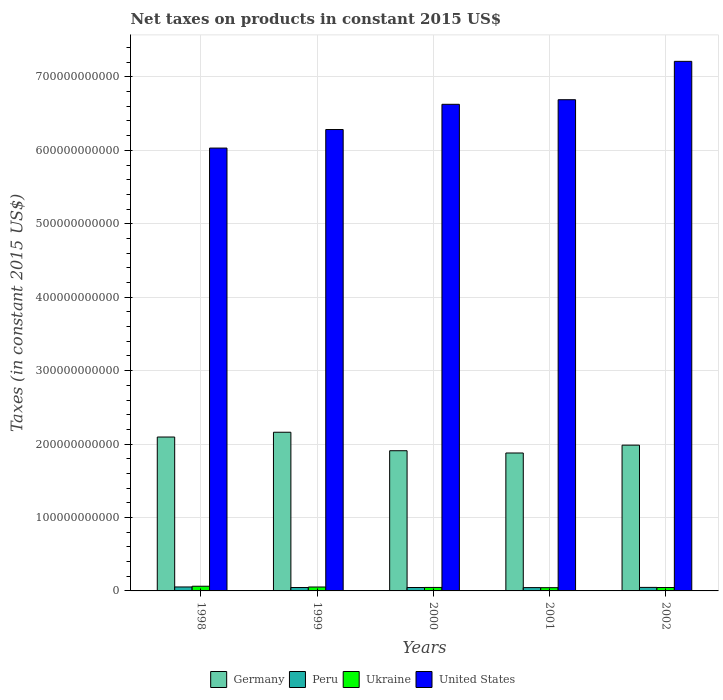How many different coloured bars are there?
Your answer should be compact. 4. Are the number of bars per tick equal to the number of legend labels?
Your response must be concise. Yes. How many bars are there on the 2nd tick from the left?
Offer a terse response. 4. In how many cases, is the number of bars for a given year not equal to the number of legend labels?
Offer a very short reply. 0. What is the net taxes on products in United States in 2002?
Provide a succinct answer. 7.21e+11. Across all years, what is the maximum net taxes on products in Ukraine?
Provide a short and direct response. 6.38e+09. Across all years, what is the minimum net taxes on products in United States?
Your answer should be compact. 6.03e+11. What is the total net taxes on products in United States in the graph?
Your answer should be compact. 3.28e+12. What is the difference between the net taxes on products in Peru in 1999 and that in 2000?
Ensure brevity in your answer.  -1.66e+07. What is the difference between the net taxes on products in Peru in 2001 and the net taxes on products in Ukraine in 1999?
Your response must be concise. -7.92e+08. What is the average net taxes on products in United States per year?
Ensure brevity in your answer.  6.57e+11. In the year 2001, what is the difference between the net taxes on products in United States and net taxes on products in Germany?
Offer a terse response. 4.81e+11. In how many years, is the net taxes on products in Peru greater than 40000000000 US$?
Provide a succinct answer. 0. What is the ratio of the net taxes on products in Germany in 1999 to that in 2001?
Your response must be concise. 1.15. Is the net taxes on products in Peru in 1999 less than that in 2000?
Provide a succinct answer. Yes. Is the difference between the net taxes on products in United States in 2000 and 2001 greater than the difference between the net taxes on products in Germany in 2000 and 2001?
Your response must be concise. No. What is the difference between the highest and the second highest net taxes on products in United States?
Offer a terse response. 5.22e+1. What is the difference between the highest and the lowest net taxes on products in Ukraine?
Provide a short and direct response. 1.97e+09. In how many years, is the net taxes on products in Peru greater than the average net taxes on products in Peru taken over all years?
Offer a very short reply. 1. Is the sum of the net taxes on products in Peru in 2000 and 2002 greater than the maximum net taxes on products in United States across all years?
Keep it short and to the point. No. Is it the case that in every year, the sum of the net taxes on products in United States and net taxes on products in Peru is greater than the sum of net taxes on products in Ukraine and net taxes on products in Germany?
Your answer should be compact. Yes. How many bars are there?
Your response must be concise. 20. Are all the bars in the graph horizontal?
Make the answer very short. No. How many years are there in the graph?
Make the answer very short. 5. What is the difference between two consecutive major ticks on the Y-axis?
Make the answer very short. 1.00e+11. Where does the legend appear in the graph?
Ensure brevity in your answer.  Bottom center. How many legend labels are there?
Provide a succinct answer. 4. What is the title of the graph?
Provide a succinct answer. Net taxes on products in constant 2015 US$. What is the label or title of the Y-axis?
Provide a succinct answer. Taxes (in constant 2015 US$). What is the Taxes (in constant 2015 US$) of Germany in 1998?
Provide a short and direct response. 2.10e+11. What is the Taxes (in constant 2015 US$) in Peru in 1998?
Provide a short and direct response. 5.39e+09. What is the Taxes (in constant 2015 US$) of Ukraine in 1998?
Give a very brief answer. 6.38e+09. What is the Taxes (in constant 2015 US$) of United States in 1998?
Keep it short and to the point. 6.03e+11. What is the Taxes (in constant 2015 US$) of Germany in 1999?
Give a very brief answer. 2.16e+11. What is the Taxes (in constant 2015 US$) in Peru in 1999?
Ensure brevity in your answer.  4.64e+09. What is the Taxes (in constant 2015 US$) in Ukraine in 1999?
Offer a terse response. 5.32e+09. What is the Taxes (in constant 2015 US$) in United States in 1999?
Keep it short and to the point. 6.28e+11. What is the Taxes (in constant 2015 US$) of Germany in 2000?
Offer a very short reply. 1.91e+11. What is the Taxes (in constant 2015 US$) of Peru in 2000?
Your response must be concise. 4.65e+09. What is the Taxes (in constant 2015 US$) in Ukraine in 2000?
Give a very brief answer. 4.74e+09. What is the Taxes (in constant 2015 US$) of United States in 2000?
Ensure brevity in your answer.  6.63e+11. What is the Taxes (in constant 2015 US$) in Germany in 2001?
Make the answer very short. 1.88e+11. What is the Taxes (in constant 2015 US$) of Peru in 2001?
Offer a very short reply. 4.53e+09. What is the Taxes (in constant 2015 US$) of Ukraine in 2001?
Provide a succinct answer. 4.41e+09. What is the Taxes (in constant 2015 US$) in United States in 2001?
Make the answer very short. 6.69e+11. What is the Taxes (in constant 2015 US$) of Germany in 2002?
Your answer should be compact. 1.99e+11. What is the Taxes (in constant 2015 US$) in Peru in 2002?
Your response must be concise. 4.80e+09. What is the Taxes (in constant 2015 US$) in Ukraine in 2002?
Offer a very short reply. 4.62e+09. What is the Taxes (in constant 2015 US$) in United States in 2002?
Ensure brevity in your answer.  7.21e+11. Across all years, what is the maximum Taxes (in constant 2015 US$) in Germany?
Ensure brevity in your answer.  2.16e+11. Across all years, what is the maximum Taxes (in constant 2015 US$) of Peru?
Offer a terse response. 5.39e+09. Across all years, what is the maximum Taxes (in constant 2015 US$) in Ukraine?
Offer a terse response. 6.38e+09. Across all years, what is the maximum Taxes (in constant 2015 US$) in United States?
Ensure brevity in your answer.  7.21e+11. Across all years, what is the minimum Taxes (in constant 2015 US$) of Germany?
Keep it short and to the point. 1.88e+11. Across all years, what is the minimum Taxes (in constant 2015 US$) in Peru?
Give a very brief answer. 4.53e+09. Across all years, what is the minimum Taxes (in constant 2015 US$) in Ukraine?
Make the answer very short. 4.41e+09. Across all years, what is the minimum Taxes (in constant 2015 US$) of United States?
Offer a very short reply. 6.03e+11. What is the total Taxes (in constant 2015 US$) of Germany in the graph?
Give a very brief answer. 1.00e+12. What is the total Taxes (in constant 2015 US$) of Peru in the graph?
Your answer should be compact. 2.40e+1. What is the total Taxes (in constant 2015 US$) of Ukraine in the graph?
Ensure brevity in your answer.  2.55e+1. What is the total Taxes (in constant 2015 US$) of United States in the graph?
Ensure brevity in your answer.  3.28e+12. What is the difference between the Taxes (in constant 2015 US$) of Germany in 1998 and that in 1999?
Provide a succinct answer. -6.52e+09. What is the difference between the Taxes (in constant 2015 US$) of Peru in 1998 and that in 1999?
Provide a succinct answer. 7.55e+08. What is the difference between the Taxes (in constant 2015 US$) of Ukraine in 1998 and that in 1999?
Your response must be concise. 1.06e+09. What is the difference between the Taxes (in constant 2015 US$) of United States in 1998 and that in 1999?
Give a very brief answer. -2.53e+1. What is the difference between the Taxes (in constant 2015 US$) of Germany in 1998 and that in 2000?
Your answer should be very brief. 1.87e+1. What is the difference between the Taxes (in constant 2015 US$) in Peru in 1998 and that in 2000?
Your answer should be very brief. 7.38e+08. What is the difference between the Taxes (in constant 2015 US$) in Ukraine in 1998 and that in 2000?
Your answer should be very brief. 1.63e+09. What is the difference between the Taxes (in constant 2015 US$) in United States in 1998 and that in 2000?
Keep it short and to the point. -5.96e+1. What is the difference between the Taxes (in constant 2015 US$) of Germany in 1998 and that in 2001?
Your answer should be compact. 2.17e+1. What is the difference between the Taxes (in constant 2015 US$) of Peru in 1998 and that in 2001?
Your response must be concise. 8.63e+08. What is the difference between the Taxes (in constant 2015 US$) in Ukraine in 1998 and that in 2001?
Ensure brevity in your answer.  1.97e+09. What is the difference between the Taxes (in constant 2015 US$) in United States in 1998 and that in 2001?
Provide a short and direct response. -6.59e+1. What is the difference between the Taxes (in constant 2015 US$) in Germany in 1998 and that in 2002?
Keep it short and to the point. 1.11e+1. What is the difference between the Taxes (in constant 2015 US$) of Peru in 1998 and that in 2002?
Offer a very short reply. 5.91e+08. What is the difference between the Taxes (in constant 2015 US$) in Ukraine in 1998 and that in 2002?
Offer a terse response. 1.76e+09. What is the difference between the Taxes (in constant 2015 US$) of United States in 1998 and that in 2002?
Make the answer very short. -1.18e+11. What is the difference between the Taxes (in constant 2015 US$) in Germany in 1999 and that in 2000?
Provide a succinct answer. 2.52e+1. What is the difference between the Taxes (in constant 2015 US$) in Peru in 1999 and that in 2000?
Provide a short and direct response. -1.66e+07. What is the difference between the Taxes (in constant 2015 US$) in Ukraine in 1999 and that in 2000?
Keep it short and to the point. 5.77e+08. What is the difference between the Taxes (in constant 2015 US$) in United States in 1999 and that in 2000?
Offer a terse response. -3.43e+1. What is the difference between the Taxes (in constant 2015 US$) in Germany in 1999 and that in 2001?
Ensure brevity in your answer.  2.83e+1. What is the difference between the Taxes (in constant 2015 US$) of Peru in 1999 and that in 2001?
Provide a short and direct response. 1.08e+08. What is the difference between the Taxes (in constant 2015 US$) of Ukraine in 1999 and that in 2001?
Keep it short and to the point. 9.09e+08. What is the difference between the Taxes (in constant 2015 US$) of United States in 1999 and that in 2001?
Your response must be concise. -4.06e+1. What is the difference between the Taxes (in constant 2015 US$) of Germany in 1999 and that in 2002?
Make the answer very short. 1.76e+1. What is the difference between the Taxes (in constant 2015 US$) in Peru in 1999 and that in 2002?
Give a very brief answer. -1.64e+08. What is the difference between the Taxes (in constant 2015 US$) of Ukraine in 1999 and that in 2002?
Provide a short and direct response. 6.99e+08. What is the difference between the Taxes (in constant 2015 US$) of United States in 1999 and that in 2002?
Offer a very short reply. -9.28e+1. What is the difference between the Taxes (in constant 2015 US$) in Germany in 2000 and that in 2001?
Ensure brevity in your answer.  3.09e+09. What is the difference between the Taxes (in constant 2015 US$) of Peru in 2000 and that in 2001?
Keep it short and to the point. 1.25e+08. What is the difference between the Taxes (in constant 2015 US$) in Ukraine in 2000 and that in 2001?
Your answer should be compact. 3.32e+08. What is the difference between the Taxes (in constant 2015 US$) in United States in 2000 and that in 2001?
Keep it short and to the point. -6.25e+09. What is the difference between the Taxes (in constant 2015 US$) of Germany in 2000 and that in 2002?
Ensure brevity in your answer.  -7.58e+09. What is the difference between the Taxes (in constant 2015 US$) of Peru in 2000 and that in 2002?
Your answer should be compact. -1.47e+08. What is the difference between the Taxes (in constant 2015 US$) in Ukraine in 2000 and that in 2002?
Your answer should be compact. 1.23e+08. What is the difference between the Taxes (in constant 2015 US$) of United States in 2000 and that in 2002?
Keep it short and to the point. -5.85e+1. What is the difference between the Taxes (in constant 2015 US$) of Germany in 2001 and that in 2002?
Provide a succinct answer. -1.07e+1. What is the difference between the Taxes (in constant 2015 US$) in Peru in 2001 and that in 2002?
Ensure brevity in your answer.  -2.72e+08. What is the difference between the Taxes (in constant 2015 US$) of Ukraine in 2001 and that in 2002?
Your answer should be compact. -2.10e+08. What is the difference between the Taxes (in constant 2015 US$) in United States in 2001 and that in 2002?
Provide a succinct answer. -5.22e+1. What is the difference between the Taxes (in constant 2015 US$) in Germany in 1998 and the Taxes (in constant 2015 US$) in Peru in 1999?
Provide a short and direct response. 2.05e+11. What is the difference between the Taxes (in constant 2015 US$) of Germany in 1998 and the Taxes (in constant 2015 US$) of Ukraine in 1999?
Make the answer very short. 2.04e+11. What is the difference between the Taxes (in constant 2015 US$) in Germany in 1998 and the Taxes (in constant 2015 US$) in United States in 1999?
Your answer should be compact. -4.19e+11. What is the difference between the Taxes (in constant 2015 US$) in Peru in 1998 and the Taxes (in constant 2015 US$) in Ukraine in 1999?
Your answer should be very brief. 7.12e+07. What is the difference between the Taxes (in constant 2015 US$) of Peru in 1998 and the Taxes (in constant 2015 US$) of United States in 1999?
Give a very brief answer. -6.23e+11. What is the difference between the Taxes (in constant 2015 US$) of Ukraine in 1998 and the Taxes (in constant 2015 US$) of United States in 1999?
Ensure brevity in your answer.  -6.22e+11. What is the difference between the Taxes (in constant 2015 US$) in Germany in 1998 and the Taxes (in constant 2015 US$) in Peru in 2000?
Ensure brevity in your answer.  2.05e+11. What is the difference between the Taxes (in constant 2015 US$) of Germany in 1998 and the Taxes (in constant 2015 US$) of Ukraine in 2000?
Give a very brief answer. 2.05e+11. What is the difference between the Taxes (in constant 2015 US$) of Germany in 1998 and the Taxes (in constant 2015 US$) of United States in 2000?
Give a very brief answer. -4.53e+11. What is the difference between the Taxes (in constant 2015 US$) of Peru in 1998 and the Taxes (in constant 2015 US$) of Ukraine in 2000?
Keep it short and to the point. 6.48e+08. What is the difference between the Taxes (in constant 2015 US$) in Peru in 1998 and the Taxes (in constant 2015 US$) in United States in 2000?
Make the answer very short. -6.57e+11. What is the difference between the Taxes (in constant 2015 US$) in Ukraine in 1998 and the Taxes (in constant 2015 US$) in United States in 2000?
Make the answer very short. -6.56e+11. What is the difference between the Taxes (in constant 2015 US$) of Germany in 1998 and the Taxes (in constant 2015 US$) of Peru in 2001?
Your answer should be compact. 2.05e+11. What is the difference between the Taxes (in constant 2015 US$) of Germany in 1998 and the Taxes (in constant 2015 US$) of Ukraine in 2001?
Ensure brevity in your answer.  2.05e+11. What is the difference between the Taxes (in constant 2015 US$) in Germany in 1998 and the Taxes (in constant 2015 US$) in United States in 2001?
Provide a succinct answer. -4.59e+11. What is the difference between the Taxes (in constant 2015 US$) in Peru in 1998 and the Taxes (in constant 2015 US$) in Ukraine in 2001?
Provide a short and direct response. 9.80e+08. What is the difference between the Taxes (in constant 2015 US$) of Peru in 1998 and the Taxes (in constant 2015 US$) of United States in 2001?
Keep it short and to the point. -6.64e+11. What is the difference between the Taxes (in constant 2015 US$) in Ukraine in 1998 and the Taxes (in constant 2015 US$) in United States in 2001?
Your answer should be very brief. -6.63e+11. What is the difference between the Taxes (in constant 2015 US$) of Germany in 1998 and the Taxes (in constant 2015 US$) of Peru in 2002?
Your response must be concise. 2.05e+11. What is the difference between the Taxes (in constant 2015 US$) in Germany in 1998 and the Taxes (in constant 2015 US$) in Ukraine in 2002?
Make the answer very short. 2.05e+11. What is the difference between the Taxes (in constant 2015 US$) of Germany in 1998 and the Taxes (in constant 2015 US$) of United States in 2002?
Provide a succinct answer. -5.12e+11. What is the difference between the Taxes (in constant 2015 US$) of Peru in 1998 and the Taxes (in constant 2015 US$) of Ukraine in 2002?
Your answer should be compact. 7.71e+08. What is the difference between the Taxes (in constant 2015 US$) in Peru in 1998 and the Taxes (in constant 2015 US$) in United States in 2002?
Give a very brief answer. -7.16e+11. What is the difference between the Taxes (in constant 2015 US$) in Ukraine in 1998 and the Taxes (in constant 2015 US$) in United States in 2002?
Your answer should be very brief. -7.15e+11. What is the difference between the Taxes (in constant 2015 US$) of Germany in 1999 and the Taxes (in constant 2015 US$) of Peru in 2000?
Keep it short and to the point. 2.11e+11. What is the difference between the Taxes (in constant 2015 US$) in Germany in 1999 and the Taxes (in constant 2015 US$) in Ukraine in 2000?
Provide a short and direct response. 2.11e+11. What is the difference between the Taxes (in constant 2015 US$) in Germany in 1999 and the Taxes (in constant 2015 US$) in United States in 2000?
Your answer should be compact. -4.47e+11. What is the difference between the Taxes (in constant 2015 US$) of Peru in 1999 and the Taxes (in constant 2015 US$) of Ukraine in 2000?
Keep it short and to the point. -1.07e+08. What is the difference between the Taxes (in constant 2015 US$) of Peru in 1999 and the Taxes (in constant 2015 US$) of United States in 2000?
Give a very brief answer. -6.58e+11. What is the difference between the Taxes (in constant 2015 US$) in Ukraine in 1999 and the Taxes (in constant 2015 US$) in United States in 2000?
Give a very brief answer. -6.57e+11. What is the difference between the Taxes (in constant 2015 US$) in Germany in 1999 and the Taxes (in constant 2015 US$) in Peru in 2001?
Offer a terse response. 2.12e+11. What is the difference between the Taxes (in constant 2015 US$) in Germany in 1999 and the Taxes (in constant 2015 US$) in Ukraine in 2001?
Make the answer very short. 2.12e+11. What is the difference between the Taxes (in constant 2015 US$) in Germany in 1999 and the Taxes (in constant 2015 US$) in United States in 2001?
Your answer should be very brief. -4.53e+11. What is the difference between the Taxes (in constant 2015 US$) in Peru in 1999 and the Taxes (in constant 2015 US$) in Ukraine in 2001?
Your answer should be compact. 2.25e+08. What is the difference between the Taxes (in constant 2015 US$) in Peru in 1999 and the Taxes (in constant 2015 US$) in United States in 2001?
Keep it short and to the point. -6.64e+11. What is the difference between the Taxes (in constant 2015 US$) of Ukraine in 1999 and the Taxes (in constant 2015 US$) of United States in 2001?
Provide a succinct answer. -6.64e+11. What is the difference between the Taxes (in constant 2015 US$) of Germany in 1999 and the Taxes (in constant 2015 US$) of Peru in 2002?
Your answer should be very brief. 2.11e+11. What is the difference between the Taxes (in constant 2015 US$) of Germany in 1999 and the Taxes (in constant 2015 US$) of Ukraine in 2002?
Keep it short and to the point. 2.11e+11. What is the difference between the Taxes (in constant 2015 US$) of Germany in 1999 and the Taxes (in constant 2015 US$) of United States in 2002?
Make the answer very short. -5.05e+11. What is the difference between the Taxes (in constant 2015 US$) of Peru in 1999 and the Taxes (in constant 2015 US$) of Ukraine in 2002?
Make the answer very short. 1.58e+07. What is the difference between the Taxes (in constant 2015 US$) of Peru in 1999 and the Taxes (in constant 2015 US$) of United States in 2002?
Your response must be concise. -7.17e+11. What is the difference between the Taxes (in constant 2015 US$) in Ukraine in 1999 and the Taxes (in constant 2015 US$) in United States in 2002?
Your answer should be compact. -7.16e+11. What is the difference between the Taxes (in constant 2015 US$) in Germany in 2000 and the Taxes (in constant 2015 US$) in Peru in 2001?
Keep it short and to the point. 1.86e+11. What is the difference between the Taxes (in constant 2015 US$) in Germany in 2000 and the Taxes (in constant 2015 US$) in Ukraine in 2001?
Offer a terse response. 1.87e+11. What is the difference between the Taxes (in constant 2015 US$) of Germany in 2000 and the Taxes (in constant 2015 US$) of United States in 2001?
Keep it short and to the point. -4.78e+11. What is the difference between the Taxes (in constant 2015 US$) in Peru in 2000 and the Taxes (in constant 2015 US$) in Ukraine in 2001?
Ensure brevity in your answer.  2.42e+08. What is the difference between the Taxes (in constant 2015 US$) in Peru in 2000 and the Taxes (in constant 2015 US$) in United States in 2001?
Your answer should be very brief. -6.64e+11. What is the difference between the Taxes (in constant 2015 US$) in Ukraine in 2000 and the Taxes (in constant 2015 US$) in United States in 2001?
Your answer should be very brief. -6.64e+11. What is the difference between the Taxes (in constant 2015 US$) of Germany in 2000 and the Taxes (in constant 2015 US$) of Peru in 2002?
Make the answer very short. 1.86e+11. What is the difference between the Taxes (in constant 2015 US$) in Germany in 2000 and the Taxes (in constant 2015 US$) in Ukraine in 2002?
Your response must be concise. 1.86e+11. What is the difference between the Taxes (in constant 2015 US$) of Germany in 2000 and the Taxes (in constant 2015 US$) of United States in 2002?
Make the answer very short. -5.30e+11. What is the difference between the Taxes (in constant 2015 US$) of Peru in 2000 and the Taxes (in constant 2015 US$) of Ukraine in 2002?
Give a very brief answer. 3.24e+07. What is the difference between the Taxes (in constant 2015 US$) of Peru in 2000 and the Taxes (in constant 2015 US$) of United States in 2002?
Offer a very short reply. -7.17e+11. What is the difference between the Taxes (in constant 2015 US$) of Ukraine in 2000 and the Taxes (in constant 2015 US$) of United States in 2002?
Provide a succinct answer. -7.16e+11. What is the difference between the Taxes (in constant 2015 US$) of Germany in 2001 and the Taxes (in constant 2015 US$) of Peru in 2002?
Offer a very short reply. 1.83e+11. What is the difference between the Taxes (in constant 2015 US$) in Germany in 2001 and the Taxes (in constant 2015 US$) in Ukraine in 2002?
Your answer should be compact. 1.83e+11. What is the difference between the Taxes (in constant 2015 US$) of Germany in 2001 and the Taxes (in constant 2015 US$) of United States in 2002?
Keep it short and to the point. -5.33e+11. What is the difference between the Taxes (in constant 2015 US$) of Peru in 2001 and the Taxes (in constant 2015 US$) of Ukraine in 2002?
Make the answer very short. -9.27e+07. What is the difference between the Taxes (in constant 2015 US$) in Peru in 2001 and the Taxes (in constant 2015 US$) in United States in 2002?
Offer a very short reply. -7.17e+11. What is the difference between the Taxes (in constant 2015 US$) in Ukraine in 2001 and the Taxes (in constant 2015 US$) in United States in 2002?
Provide a succinct answer. -7.17e+11. What is the average Taxes (in constant 2015 US$) of Germany per year?
Provide a short and direct response. 2.01e+11. What is the average Taxes (in constant 2015 US$) in Peru per year?
Provide a short and direct response. 4.80e+09. What is the average Taxes (in constant 2015 US$) of Ukraine per year?
Provide a succinct answer. 5.10e+09. What is the average Taxes (in constant 2015 US$) in United States per year?
Make the answer very short. 6.57e+11. In the year 1998, what is the difference between the Taxes (in constant 2015 US$) of Germany and Taxes (in constant 2015 US$) of Peru?
Your answer should be compact. 2.04e+11. In the year 1998, what is the difference between the Taxes (in constant 2015 US$) in Germany and Taxes (in constant 2015 US$) in Ukraine?
Ensure brevity in your answer.  2.03e+11. In the year 1998, what is the difference between the Taxes (in constant 2015 US$) of Germany and Taxes (in constant 2015 US$) of United States?
Your response must be concise. -3.94e+11. In the year 1998, what is the difference between the Taxes (in constant 2015 US$) in Peru and Taxes (in constant 2015 US$) in Ukraine?
Provide a short and direct response. -9.87e+08. In the year 1998, what is the difference between the Taxes (in constant 2015 US$) in Peru and Taxes (in constant 2015 US$) in United States?
Keep it short and to the point. -5.98e+11. In the year 1998, what is the difference between the Taxes (in constant 2015 US$) in Ukraine and Taxes (in constant 2015 US$) in United States?
Your answer should be compact. -5.97e+11. In the year 1999, what is the difference between the Taxes (in constant 2015 US$) of Germany and Taxes (in constant 2015 US$) of Peru?
Your answer should be very brief. 2.11e+11. In the year 1999, what is the difference between the Taxes (in constant 2015 US$) in Germany and Taxes (in constant 2015 US$) in Ukraine?
Give a very brief answer. 2.11e+11. In the year 1999, what is the difference between the Taxes (in constant 2015 US$) in Germany and Taxes (in constant 2015 US$) in United States?
Provide a succinct answer. -4.12e+11. In the year 1999, what is the difference between the Taxes (in constant 2015 US$) in Peru and Taxes (in constant 2015 US$) in Ukraine?
Your answer should be very brief. -6.84e+08. In the year 1999, what is the difference between the Taxes (in constant 2015 US$) of Peru and Taxes (in constant 2015 US$) of United States?
Offer a terse response. -6.24e+11. In the year 1999, what is the difference between the Taxes (in constant 2015 US$) in Ukraine and Taxes (in constant 2015 US$) in United States?
Keep it short and to the point. -6.23e+11. In the year 2000, what is the difference between the Taxes (in constant 2015 US$) of Germany and Taxes (in constant 2015 US$) of Peru?
Provide a short and direct response. 1.86e+11. In the year 2000, what is the difference between the Taxes (in constant 2015 US$) in Germany and Taxes (in constant 2015 US$) in Ukraine?
Give a very brief answer. 1.86e+11. In the year 2000, what is the difference between the Taxes (in constant 2015 US$) of Germany and Taxes (in constant 2015 US$) of United States?
Your answer should be compact. -4.72e+11. In the year 2000, what is the difference between the Taxes (in constant 2015 US$) in Peru and Taxes (in constant 2015 US$) in Ukraine?
Your answer should be very brief. -9.02e+07. In the year 2000, what is the difference between the Taxes (in constant 2015 US$) in Peru and Taxes (in constant 2015 US$) in United States?
Ensure brevity in your answer.  -6.58e+11. In the year 2000, what is the difference between the Taxes (in constant 2015 US$) in Ukraine and Taxes (in constant 2015 US$) in United States?
Your answer should be compact. -6.58e+11. In the year 2001, what is the difference between the Taxes (in constant 2015 US$) of Germany and Taxes (in constant 2015 US$) of Peru?
Provide a succinct answer. 1.83e+11. In the year 2001, what is the difference between the Taxes (in constant 2015 US$) of Germany and Taxes (in constant 2015 US$) of Ukraine?
Your answer should be compact. 1.83e+11. In the year 2001, what is the difference between the Taxes (in constant 2015 US$) of Germany and Taxes (in constant 2015 US$) of United States?
Give a very brief answer. -4.81e+11. In the year 2001, what is the difference between the Taxes (in constant 2015 US$) of Peru and Taxes (in constant 2015 US$) of Ukraine?
Offer a terse response. 1.17e+08. In the year 2001, what is the difference between the Taxes (in constant 2015 US$) of Peru and Taxes (in constant 2015 US$) of United States?
Ensure brevity in your answer.  -6.64e+11. In the year 2001, what is the difference between the Taxes (in constant 2015 US$) of Ukraine and Taxes (in constant 2015 US$) of United States?
Offer a very short reply. -6.65e+11. In the year 2002, what is the difference between the Taxes (in constant 2015 US$) in Germany and Taxes (in constant 2015 US$) in Peru?
Your response must be concise. 1.94e+11. In the year 2002, what is the difference between the Taxes (in constant 2015 US$) in Germany and Taxes (in constant 2015 US$) in Ukraine?
Give a very brief answer. 1.94e+11. In the year 2002, what is the difference between the Taxes (in constant 2015 US$) of Germany and Taxes (in constant 2015 US$) of United States?
Your answer should be compact. -5.23e+11. In the year 2002, what is the difference between the Taxes (in constant 2015 US$) of Peru and Taxes (in constant 2015 US$) of Ukraine?
Your answer should be compact. 1.79e+08. In the year 2002, what is the difference between the Taxes (in constant 2015 US$) in Peru and Taxes (in constant 2015 US$) in United States?
Provide a short and direct response. -7.16e+11. In the year 2002, what is the difference between the Taxes (in constant 2015 US$) in Ukraine and Taxes (in constant 2015 US$) in United States?
Provide a succinct answer. -7.17e+11. What is the ratio of the Taxes (in constant 2015 US$) in Germany in 1998 to that in 1999?
Offer a terse response. 0.97. What is the ratio of the Taxes (in constant 2015 US$) in Peru in 1998 to that in 1999?
Keep it short and to the point. 1.16. What is the ratio of the Taxes (in constant 2015 US$) in Ukraine in 1998 to that in 1999?
Ensure brevity in your answer.  1.2. What is the ratio of the Taxes (in constant 2015 US$) in United States in 1998 to that in 1999?
Keep it short and to the point. 0.96. What is the ratio of the Taxes (in constant 2015 US$) of Germany in 1998 to that in 2000?
Your response must be concise. 1.1. What is the ratio of the Taxes (in constant 2015 US$) in Peru in 1998 to that in 2000?
Offer a terse response. 1.16. What is the ratio of the Taxes (in constant 2015 US$) of Ukraine in 1998 to that in 2000?
Offer a terse response. 1.34. What is the ratio of the Taxes (in constant 2015 US$) in United States in 1998 to that in 2000?
Keep it short and to the point. 0.91. What is the ratio of the Taxes (in constant 2015 US$) in Germany in 1998 to that in 2001?
Offer a very short reply. 1.12. What is the ratio of the Taxes (in constant 2015 US$) in Peru in 1998 to that in 2001?
Your answer should be compact. 1.19. What is the ratio of the Taxes (in constant 2015 US$) in Ukraine in 1998 to that in 2001?
Your answer should be compact. 1.45. What is the ratio of the Taxes (in constant 2015 US$) in United States in 1998 to that in 2001?
Offer a very short reply. 0.9. What is the ratio of the Taxes (in constant 2015 US$) in Germany in 1998 to that in 2002?
Give a very brief answer. 1.06. What is the ratio of the Taxes (in constant 2015 US$) of Peru in 1998 to that in 2002?
Your answer should be very brief. 1.12. What is the ratio of the Taxes (in constant 2015 US$) in Ukraine in 1998 to that in 2002?
Offer a very short reply. 1.38. What is the ratio of the Taxes (in constant 2015 US$) of United States in 1998 to that in 2002?
Your answer should be very brief. 0.84. What is the ratio of the Taxes (in constant 2015 US$) of Germany in 1999 to that in 2000?
Provide a short and direct response. 1.13. What is the ratio of the Taxes (in constant 2015 US$) of Ukraine in 1999 to that in 2000?
Offer a very short reply. 1.12. What is the ratio of the Taxes (in constant 2015 US$) in United States in 1999 to that in 2000?
Offer a very short reply. 0.95. What is the ratio of the Taxes (in constant 2015 US$) in Germany in 1999 to that in 2001?
Make the answer very short. 1.15. What is the ratio of the Taxes (in constant 2015 US$) in Peru in 1999 to that in 2001?
Give a very brief answer. 1.02. What is the ratio of the Taxes (in constant 2015 US$) of Ukraine in 1999 to that in 2001?
Ensure brevity in your answer.  1.21. What is the ratio of the Taxes (in constant 2015 US$) of United States in 1999 to that in 2001?
Give a very brief answer. 0.94. What is the ratio of the Taxes (in constant 2015 US$) of Germany in 1999 to that in 2002?
Make the answer very short. 1.09. What is the ratio of the Taxes (in constant 2015 US$) in Peru in 1999 to that in 2002?
Provide a short and direct response. 0.97. What is the ratio of the Taxes (in constant 2015 US$) of Ukraine in 1999 to that in 2002?
Offer a terse response. 1.15. What is the ratio of the Taxes (in constant 2015 US$) in United States in 1999 to that in 2002?
Provide a short and direct response. 0.87. What is the ratio of the Taxes (in constant 2015 US$) in Germany in 2000 to that in 2001?
Provide a short and direct response. 1.02. What is the ratio of the Taxes (in constant 2015 US$) in Peru in 2000 to that in 2001?
Keep it short and to the point. 1.03. What is the ratio of the Taxes (in constant 2015 US$) of Ukraine in 2000 to that in 2001?
Provide a succinct answer. 1.08. What is the ratio of the Taxes (in constant 2015 US$) in United States in 2000 to that in 2001?
Your answer should be compact. 0.99. What is the ratio of the Taxes (in constant 2015 US$) in Germany in 2000 to that in 2002?
Offer a very short reply. 0.96. What is the ratio of the Taxes (in constant 2015 US$) of Peru in 2000 to that in 2002?
Provide a succinct answer. 0.97. What is the ratio of the Taxes (in constant 2015 US$) in Ukraine in 2000 to that in 2002?
Give a very brief answer. 1.03. What is the ratio of the Taxes (in constant 2015 US$) of United States in 2000 to that in 2002?
Provide a short and direct response. 0.92. What is the ratio of the Taxes (in constant 2015 US$) of Germany in 2001 to that in 2002?
Offer a very short reply. 0.95. What is the ratio of the Taxes (in constant 2015 US$) in Peru in 2001 to that in 2002?
Offer a terse response. 0.94. What is the ratio of the Taxes (in constant 2015 US$) in Ukraine in 2001 to that in 2002?
Provide a succinct answer. 0.95. What is the ratio of the Taxes (in constant 2015 US$) of United States in 2001 to that in 2002?
Provide a short and direct response. 0.93. What is the difference between the highest and the second highest Taxes (in constant 2015 US$) in Germany?
Offer a very short reply. 6.52e+09. What is the difference between the highest and the second highest Taxes (in constant 2015 US$) in Peru?
Keep it short and to the point. 5.91e+08. What is the difference between the highest and the second highest Taxes (in constant 2015 US$) of Ukraine?
Give a very brief answer. 1.06e+09. What is the difference between the highest and the second highest Taxes (in constant 2015 US$) in United States?
Your response must be concise. 5.22e+1. What is the difference between the highest and the lowest Taxes (in constant 2015 US$) in Germany?
Your answer should be very brief. 2.83e+1. What is the difference between the highest and the lowest Taxes (in constant 2015 US$) of Peru?
Provide a short and direct response. 8.63e+08. What is the difference between the highest and the lowest Taxes (in constant 2015 US$) in Ukraine?
Your answer should be very brief. 1.97e+09. What is the difference between the highest and the lowest Taxes (in constant 2015 US$) of United States?
Offer a terse response. 1.18e+11. 